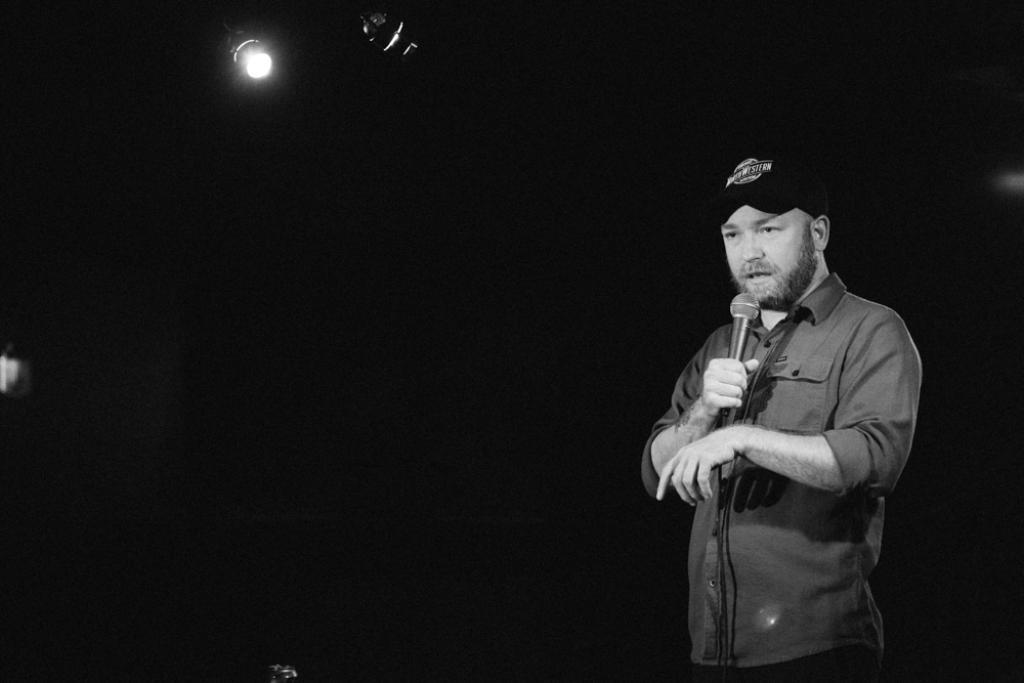Who is present in the image? There is a man in the image. What is the man wearing on his head? The man is wearing a cap. What is the man holding in his hand? The man is holding a mic. What can be seen in the background of the image? There is light visible in the background of the image. What type of horn can be heard in the image? There is no horn present in the image, and therefore no sound can be heard. 